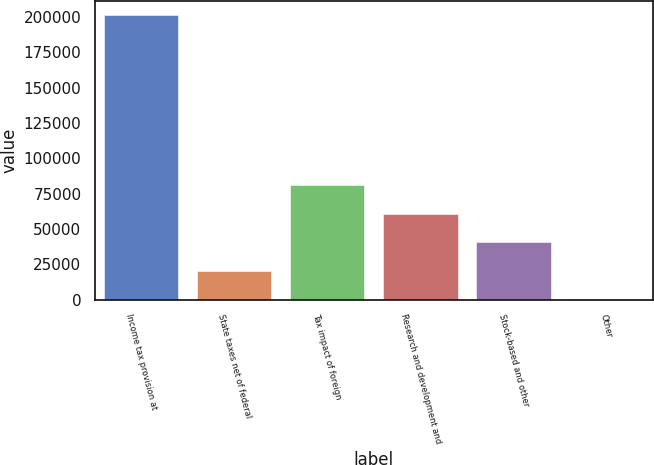Convert chart to OTSL. <chart><loc_0><loc_0><loc_500><loc_500><bar_chart><fcel>Income tax provision at<fcel>State taxes net of federal<fcel>Tax impact of foreign<fcel>Research and development and<fcel>Stock-based and other<fcel>Other<nl><fcel>201431<fcel>20687.6<fcel>80935.4<fcel>60852.8<fcel>40770.2<fcel>605<nl></chart> 